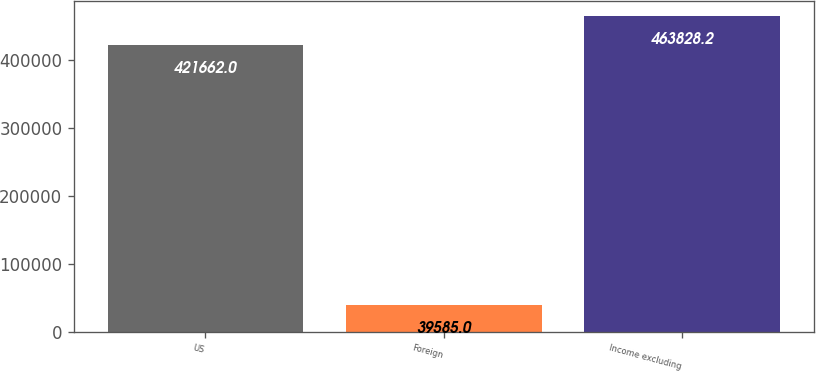Convert chart. <chart><loc_0><loc_0><loc_500><loc_500><bar_chart><fcel>US<fcel>Foreign<fcel>Income excluding<nl><fcel>421662<fcel>39585<fcel>463828<nl></chart> 